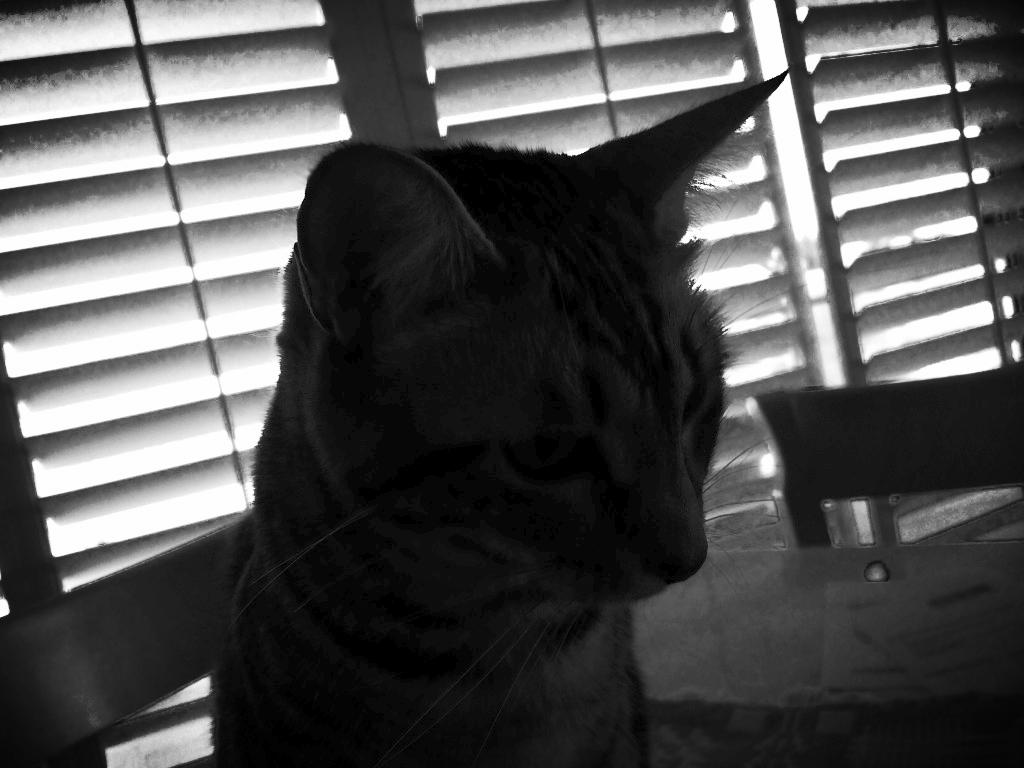What type of animal is present in the image? There is a cat in the image. What architectural feature can be seen in the image? There is a window visible in the image. What type of road can be seen in the image? There is no road visible in the image; it only features a cat and a window. 